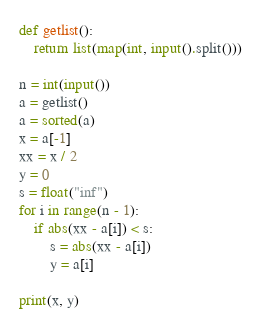Convert code to text. <code><loc_0><loc_0><loc_500><loc_500><_Python_>def getlist():
	return list(map(int, input().split()))

n = int(input())
a = getlist()
a = sorted(a)
x = a[-1]
xx = x / 2
y = 0
s = float("inf")
for i in range(n - 1):
	if abs(xx - a[i]) < s:
		s = abs(xx - a[i])
		y = a[i]

print(x, y)</code> 